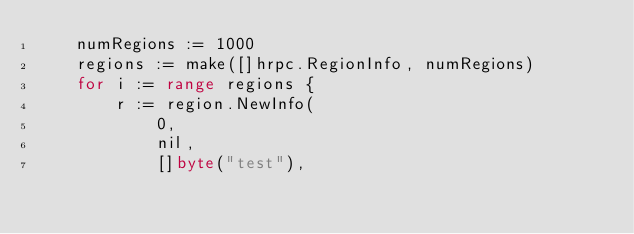Convert code to text. <code><loc_0><loc_0><loc_500><loc_500><_Go_>	numRegions := 1000
	regions := make([]hrpc.RegionInfo, numRegions)
	for i := range regions {
		r := region.NewInfo(
			0,
			nil,
			[]byte("test"),</code> 